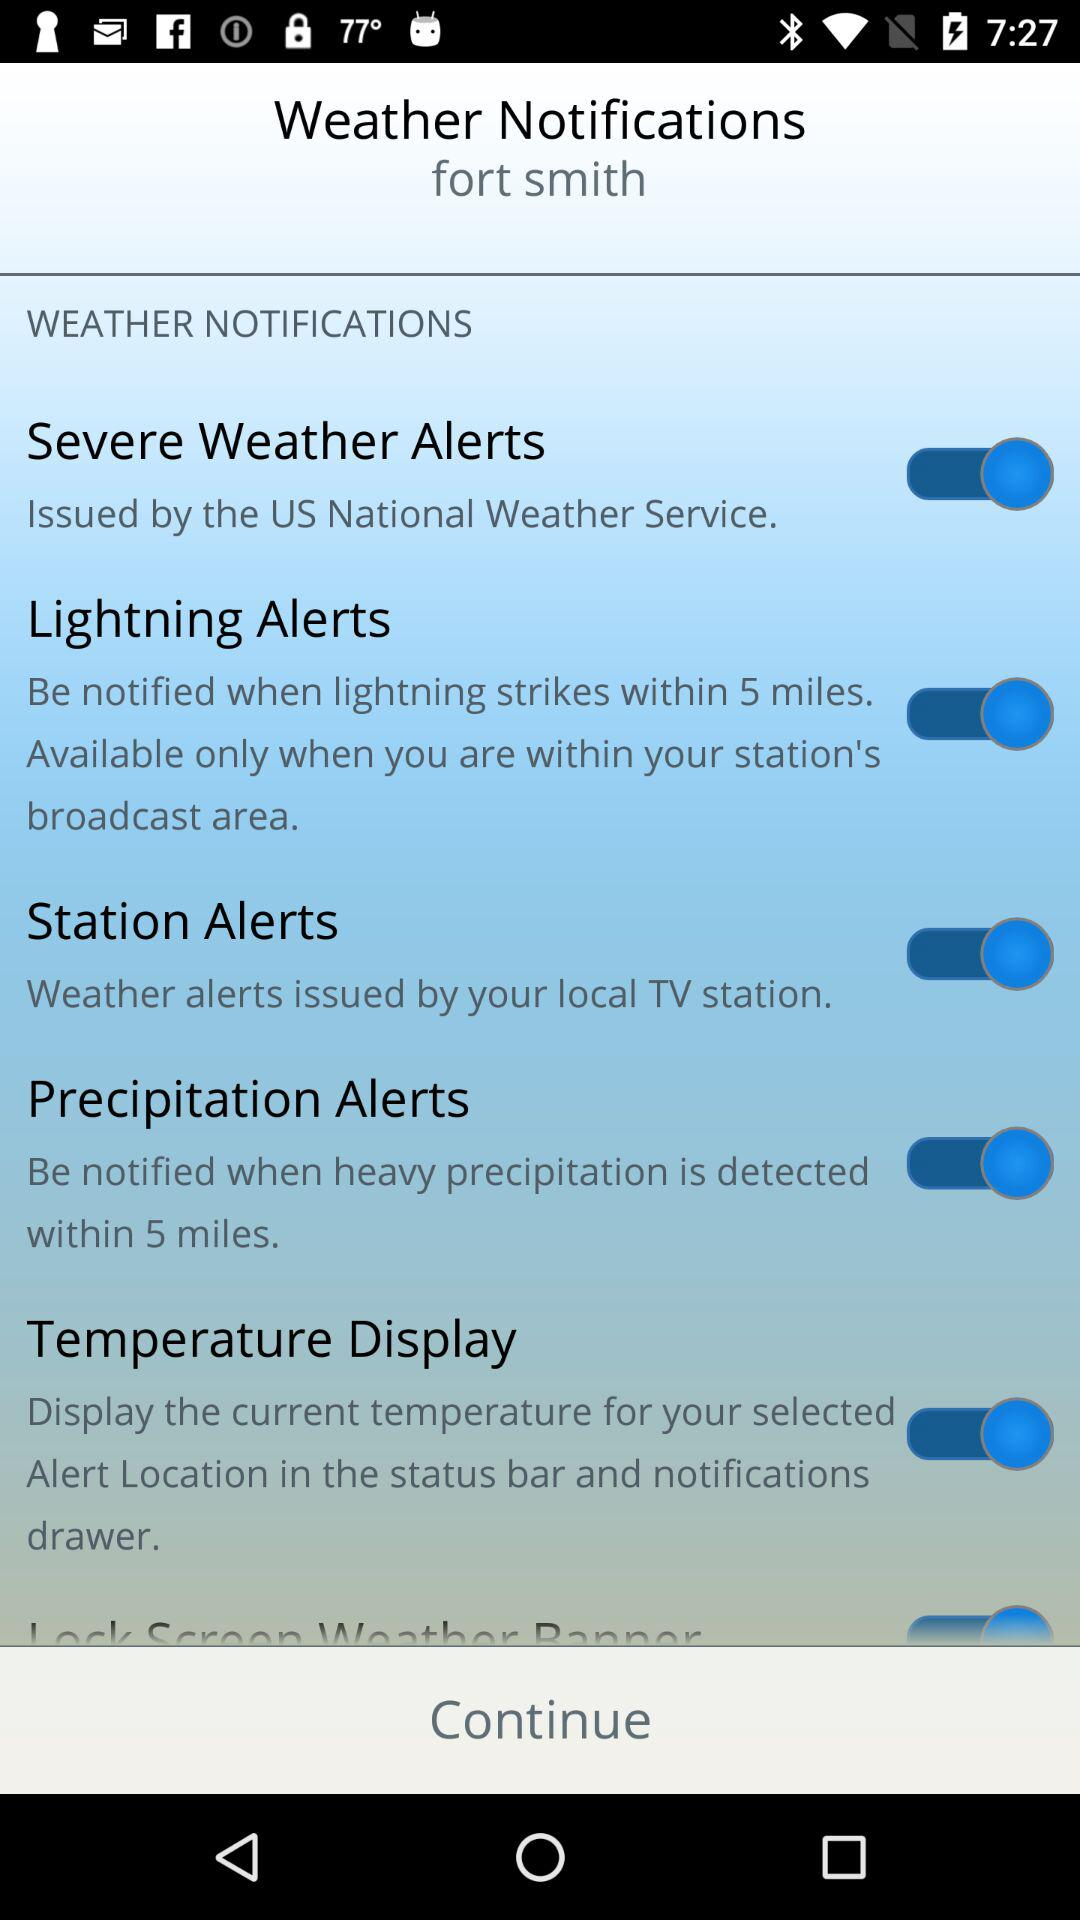How is the weather in Fort Smith?
When the provided information is insufficient, respond with <no answer>. <no answer> 